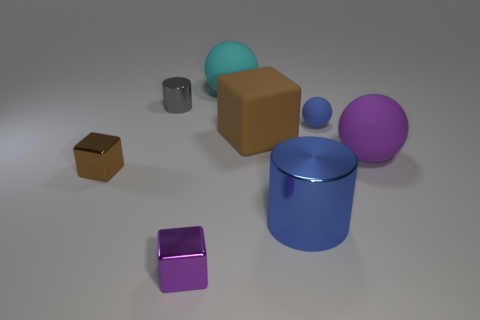Add 1 blue cubes. How many objects exist? 9 Subtract all large balls. How many balls are left? 1 Subtract all gray cylinders. How many cylinders are left? 1 Subtract 0 red spheres. How many objects are left? 8 Subtract all cylinders. How many objects are left? 6 Subtract all blue cubes. Subtract all blue spheres. How many cubes are left? 3 Subtract all gray cylinders. How many brown blocks are left? 2 Subtract all tiny blue spheres. Subtract all cyan objects. How many objects are left? 6 Add 7 purple shiny objects. How many purple shiny objects are left? 8 Add 7 big green things. How many big green things exist? 7 